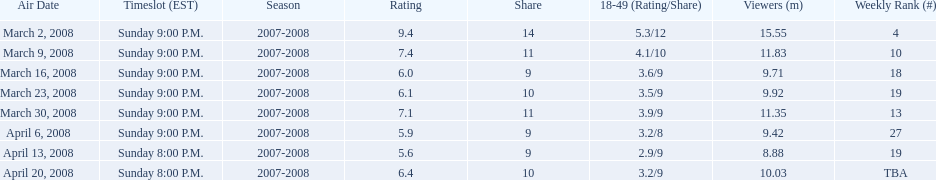In which episode was the maximum rating achieved? March 2, 2008. 